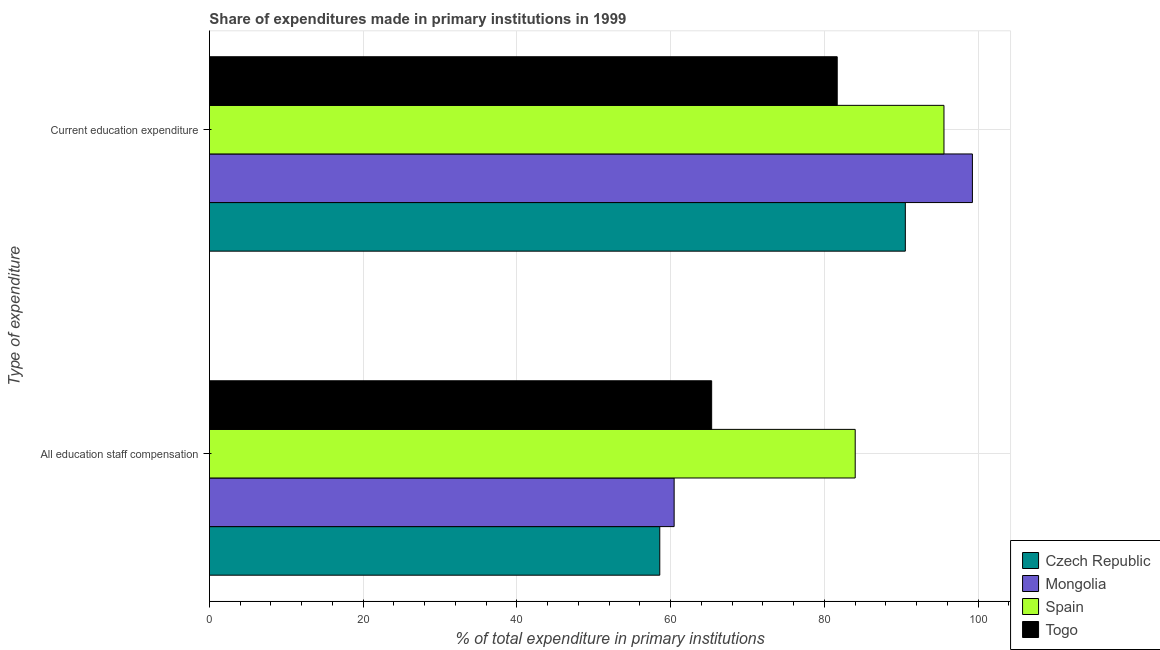How many groups of bars are there?
Your answer should be very brief. 2. Are the number of bars on each tick of the Y-axis equal?
Offer a very short reply. Yes. How many bars are there on the 1st tick from the top?
Ensure brevity in your answer.  4. What is the label of the 2nd group of bars from the top?
Offer a terse response. All education staff compensation. What is the expenditure in education in Togo?
Keep it short and to the point. 81.68. Across all countries, what is the maximum expenditure in staff compensation?
Offer a terse response. 84.02. Across all countries, what is the minimum expenditure in staff compensation?
Keep it short and to the point. 58.6. In which country was the expenditure in education minimum?
Provide a succinct answer. Togo. What is the total expenditure in staff compensation in the graph?
Keep it short and to the point. 268.42. What is the difference between the expenditure in staff compensation in Togo and that in Czech Republic?
Your answer should be compact. 6.75. What is the difference between the expenditure in education in Mongolia and the expenditure in staff compensation in Togo?
Your response must be concise. 33.92. What is the average expenditure in education per country?
Your answer should be compact. 91.77. What is the difference between the expenditure in staff compensation and expenditure in education in Spain?
Make the answer very short. -11.55. In how many countries, is the expenditure in staff compensation greater than 4 %?
Your response must be concise. 4. What is the ratio of the expenditure in education in Togo to that in Mongolia?
Ensure brevity in your answer.  0.82. Is the expenditure in education in Mongolia less than that in Togo?
Provide a short and direct response. No. What does the 2nd bar from the top in All education staff compensation represents?
Keep it short and to the point. Spain. How many bars are there?
Provide a succinct answer. 8. Are the values on the major ticks of X-axis written in scientific E-notation?
Ensure brevity in your answer.  No. Does the graph contain any zero values?
Keep it short and to the point. No. Does the graph contain grids?
Provide a short and direct response. Yes. How many legend labels are there?
Provide a succinct answer. 4. What is the title of the graph?
Make the answer very short. Share of expenditures made in primary institutions in 1999. What is the label or title of the X-axis?
Ensure brevity in your answer.  % of total expenditure in primary institutions. What is the label or title of the Y-axis?
Ensure brevity in your answer.  Type of expenditure. What is the % of total expenditure in primary institutions in Czech Republic in All education staff compensation?
Give a very brief answer. 58.6. What is the % of total expenditure in primary institutions of Mongolia in All education staff compensation?
Your response must be concise. 60.46. What is the % of total expenditure in primary institutions of Spain in All education staff compensation?
Make the answer very short. 84.02. What is the % of total expenditure in primary institutions of Togo in All education staff compensation?
Offer a terse response. 65.34. What is the % of total expenditure in primary institutions in Czech Republic in Current education expenditure?
Ensure brevity in your answer.  90.54. What is the % of total expenditure in primary institutions in Mongolia in Current education expenditure?
Your response must be concise. 99.27. What is the % of total expenditure in primary institutions of Spain in Current education expenditure?
Offer a very short reply. 95.57. What is the % of total expenditure in primary institutions of Togo in Current education expenditure?
Make the answer very short. 81.68. Across all Type of expenditure, what is the maximum % of total expenditure in primary institutions of Czech Republic?
Your answer should be very brief. 90.54. Across all Type of expenditure, what is the maximum % of total expenditure in primary institutions of Mongolia?
Your response must be concise. 99.27. Across all Type of expenditure, what is the maximum % of total expenditure in primary institutions of Spain?
Offer a very short reply. 95.57. Across all Type of expenditure, what is the maximum % of total expenditure in primary institutions of Togo?
Give a very brief answer. 81.68. Across all Type of expenditure, what is the minimum % of total expenditure in primary institutions in Czech Republic?
Offer a terse response. 58.6. Across all Type of expenditure, what is the minimum % of total expenditure in primary institutions in Mongolia?
Offer a very short reply. 60.46. Across all Type of expenditure, what is the minimum % of total expenditure in primary institutions in Spain?
Give a very brief answer. 84.02. Across all Type of expenditure, what is the minimum % of total expenditure in primary institutions in Togo?
Your answer should be very brief. 65.34. What is the total % of total expenditure in primary institutions of Czech Republic in the graph?
Your answer should be very brief. 149.14. What is the total % of total expenditure in primary institutions of Mongolia in the graph?
Give a very brief answer. 159.73. What is the total % of total expenditure in primary institutions in Spain in the graph?
Make the answer very short. 179.59. What is the total % of total expenditure in primary institutions in Togo in the graph?
Make the answer very short. 147.03. What is the difference between the % of total expenditure in primary institutions in Czech Republic in All education staff compensation and that in Current education expenditure?
Make the answer very short. -31.95. What is the difference between the % of total expenditure in primary institutions in Mongolia in All education staff compensation and that in Current education expenditure?
Offer a terse response. -38.81. What is the difference between the % of total expenditure in primary institutions of Spain in All education staff compensation and that in Current education expenditure?
Provide a succinct answer. -11.55. What is the difference between the % of total expenditure in primary institutions of Togo in All education staff compensation and that in Current education expenditure?
Provide a short and direct response. -16.34. What is the difference between the % of total expenditure in primary institutions in Czech Republic in All education staff compensation and the % of total expenditure in primary institutions in Mongolia in Current education expenditure?
Offer a very short reply. -40.67. What is the difference between the % of total expenditure in primary institutions in Czech Republic in All education staff compensation and the % of total expenditure in primary institutions in Spain in Current education expenditure?
Offer a very short reply. -36.97. What is the difference between the % of total expenditure in primary institutions of Czech Republic in All education staff compensation and the % of total expenditure in primary institutions of Togo in Current education expenditure?
Your answer should be very brief. -23.08. What is the difference between the % of total expenditure in primary institutions of Mongolia in All education staff compensation and the % of total expenditure in primary institutions of Spain in Current education expenditure?
Provide a succinct answer. -35.11. What is the difference between the % of total expenditure in primary institutions of Mongolia in All education staff compensation and the % of total expenditure in primary institutions of Togo in Current education expenditure?
Offer a terse response. -21.22. What is the difference between the % of total expenditure in primary institutions in Spain in All education staff compensation and the % of total expenditure in primary institutions in Togo in Current education expenditure?
Your answer should be compact. 2.34. What is the average % of total expenditure in primary institutions in Czech Republic per Type of expenditure?
Make the answer very short. 74.57. What is the average % of total expenditure in primary institutions of Mongolia per Type of expenditure?
Provide a succinct answer. 79.87. What is the average % of total expenditure in primary institutions of Spain per Type of expenditure?
Ensure brevity in your answer.  89.79. What is the average % of total expenditure in primary institutions of Togo per Type of expenditure?
Provide a succinct answer. 73.51. What is the difference between the % of total expenditure in primary institutions in Czech Republic and % of total expenditure in primary institutions in Mongolia in All education staff compensation?
Offer a terse response. -1.87. What is the difference between the % of total expenditure in primary institutions in Czech Republic and % of total expenditure in primary institutions in Spain in All education staff compensation?
Offer a very short reply. -25.42. What is the difference between the % of total expenditure in primary institutions in Czech Republic and % of total expenditure in primary institutions in Togo in All education staff compensation?
Your answer should be compact. -6.75. What is the difference between the % of total expenditure in primary institutions in Mongolia and % of total expenditure in primary institutions in Spain in All education staff compensation?
Ensure brevity in your answer.  -23.56. What is the difference between the % of total expenditure in primary institutions in Mongolia and % of total expenditure in primary institutions in Togo in All education staff compensation?
Your answer should be compact. -4.88. What is the difference between the % of total expenditure in primary institutions in Spain and % of total expenditure in primary institutions in Togo in All education staff compensation?
Your answer should be compact. 18.67. What is the difference between the % of total expenditure in primary institutions of Czech Republic and % of total expenditure in primary institutions of Mongolia in Current education expenditure?
Make the answer very short. -8.73. What is the difference between the % of total expenditure in primary institutions of Czech Republic and % of total expenditure in primary institutions of Spain in Current education expenditure?
Give a very brief answer. -5.03. What is the difference between the % of total expenditure in primary institutions of Czech Republic and % of total expenditure in primary institutions of Togo in Current education expenditure?
Offer a terse response. 8.86. What is the difference between the % of total expenditure in primary institutions of Mongolia and % of total expenditure in primary institutions of Spain in Current education expenditure?
Your answer should be very brief. 3.7. What is the difference between the % of total expenditure in primary institutions in Mongolia and % of total expenditure in primary institutions in Togo in Current education expenditure?
Your answer should be compact. 17.59. What is the difference between the % of total expenditure in primary institutions of Spain and % of total expenditure in primary institutions of Togo in Current education expenditure?
Your answer should be compact. 13.89. What is the ratio of the % of total expenditure in primary institutions in Czech Republic in All education staff compensation to that in Current education expenditure?
Your answer should be compact. 0.65. What is the ratio of the % of total expenditure in primary institutions in Mongolia in All education staff compensation to that in Current education expenditure?
Offer a very short reply. 0.61. What is the ratio of the % of total expenditure in primary institutions of Spain in All education staff compensation to that in Current education expenditure?
Your response must be concise. 0.88. What is the difference between the highest and the second highest % of total expenditure in primary institutions in Czech Republic?
Provide a succinct answer. 31.95. What is the difference between the highest and the second highest % of total expenditure in primary institutions in Mongolia?
Your response must be concise. 38.81. What is the difference between the highest and the second highest % of total expenditure in primary institutions in Spain?
Your response must be concise. 11.55. What is the difference between the highest and the second highest % of total expenditure in primary institutions in Togo?
Your answer should be compact. 16.34. What is the difference between the highest and the lowest % of total expenditure in primary institutions in Czech Republic?
Give a very brief answer. 31.95. What is the difference between the highest and the lowest % of total expenditure in primary institutions in Mongolia?
Your answer should be very brief. 38.81. What is the difference between the highest and the lowest % of total expenditure in primary institutions of Spain?
Provide a succinct answer. 11.55. What is the difference between the highest and the lowest % of total expenditure in primary institutions in Togo?
Your answer should be very brief. 16.34. 